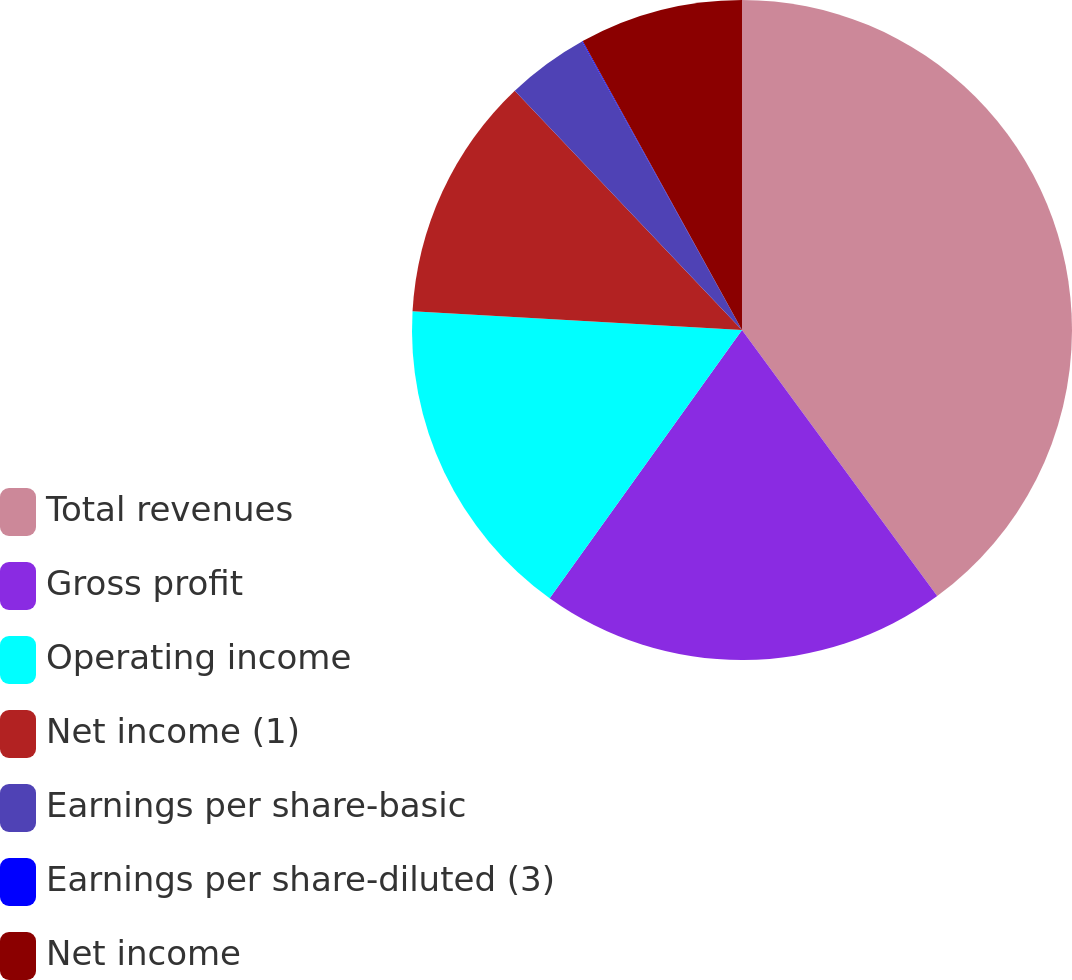Convert chart to OTSL. <chart><loc_0><loc_0><loc_500><loc_500><pie_chart><fcel>Total revenues<fcel>Gross profit<fcel>Operating income<fcel>Net income (1)<fcel>Earnings per share-basic<fcel>Earnings per share-diluted (3)<fcel>Net income<nl><fcel>39.93%<fcel>19.98%<fcel>16.0%<fcel>12.01%<fcel>4.03%<fcel>0.04%<fcel>8.02%<nl></chart> 